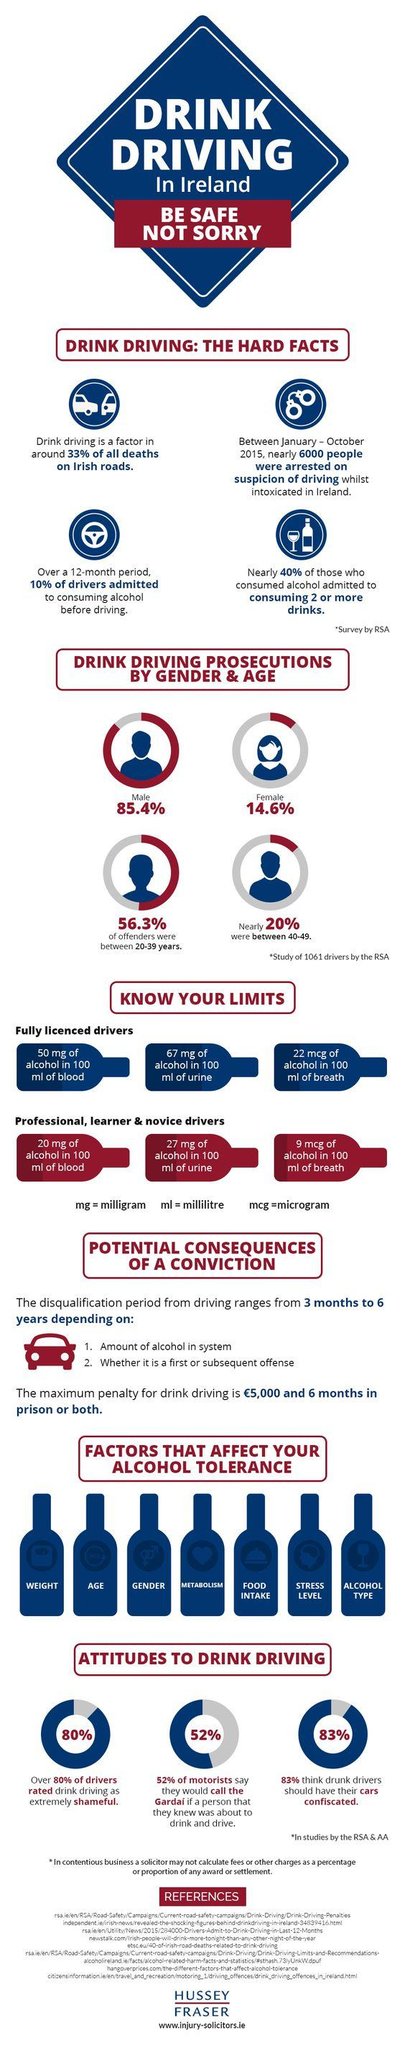Give some essential details in this illustration. The appropriate level of alcohol in the urine for individuals learning to drive is 27 mg. The legal limit for alcohol in a driver's breath is 22 micrograms per 100 milliliters of breath. According to a survey, 20% of drivers do not consider drunk driving to be a shameful activity. The number of factors that affect alcohol tolerance is 7. 